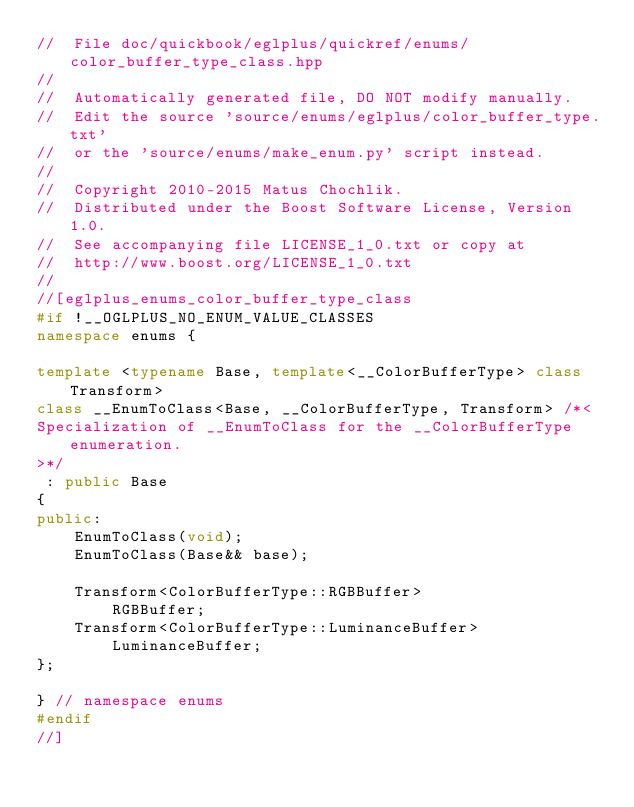Convert code to text. <code><loc_0><loc_0><loc_500><loc_500><_C++_>//  File doc/quickbook/eglplus/quickref/enums/color_buffer_type_class.hpp
//
//  Automatically generated file, DO NOT modify manually.
//  Edit the source 'source/enums/eglplus/color_buffer_type.txt'
//  or the 'source/enums/make_enum.py' script instead.
//
//  Copyright 2010-2015 Matus Chochlik.
//  Distributed under the Boost Software License, Version 1.0.
//  See accompanying file LICENSE_1_0.txt or copy at
//  http://www.boost.org/LICENSE_1_0.txt
//
//[eglplus_enums_color_buffer_type_class
#if !__OGLPLUS_NO_ENUM_VALUE_CLASSES
namespace enums {

template <typename Base, template<__ColorBufferType> class Transform>
class __EnumToClass<Base, __ColorBufferType, Transform> /*<
Specialization of __EnumToClass for the __ColorBufferType enumeration.
>*/
 : public Base
{
public:
	EnumToClass(void);
	EnumToClass(Base&& base);

	Transform<ColorBufferType::RGBBuffer>
		RGBBuffer;
	Transform<ColorBufferType::LuminanceBuffer>
		LuminanceBuffer;
};

} // namespace enums
#endif
//]

</code> 